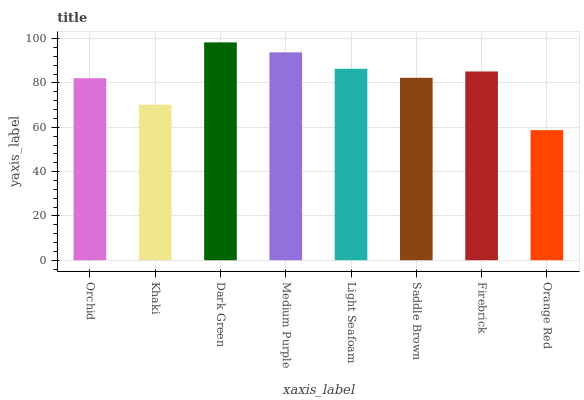Is Orange Red the minimum?
Answer yes or no. Yes. Is Dark Green the maximum?
Answer yes or no. Yes. Is Khaki the minimum?
Answer yes or no. No. Is Khaki the maximum?
Answer yes or no. No. Is Orchid greater than Khaki?
Answer yes or no. Yes. Is Khaki less than Orchid?
Answer yes or no. Yes. Is Khaki greater than Orchid?
Answer yes or no. No. Is Orchid less than Khaki?
Answer yes or no. No. Is Firebrick the high median?
Answer yes or no. Yes. Is Saddle Brown the low median?
Answer yes or no. Yes. Is Khaki the high median?
Answer yes or no. No. Is Orchid the low median?
Answer yes or no. No. 